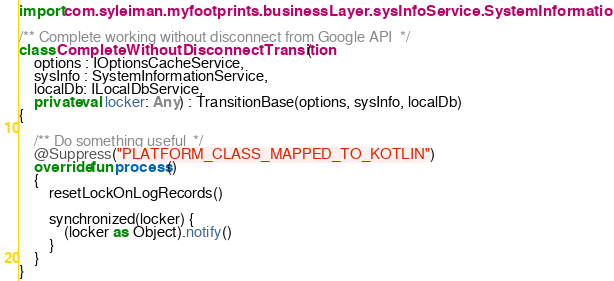<code> <loc_0><loc_0><loc_500><loc_500><_Kotlin_>import com.syleiman.myfootprints.businessLayer.sysInfoService.SystemInformationService

/** Complete working without disconnect from Google API  */
class CompleteWithoutDisconnectTransition(
    options : IOptionsCacheService,
    sysInfo : SystemInformationService,
    localDb: ILocalDbService,
    private val locker: Any) : TransitionBase(options, sysInfo, localDb)
{

    /** Do something useful  */
    @Suppress("PLATFORM_CLASS_MAPPED_TO_KOTLIN")
    override fun process()
    {
        resetLockOnLogRecords()

        synchronized(locker) {
            (locker as Object).notify()
        }
    }
}
</code> 